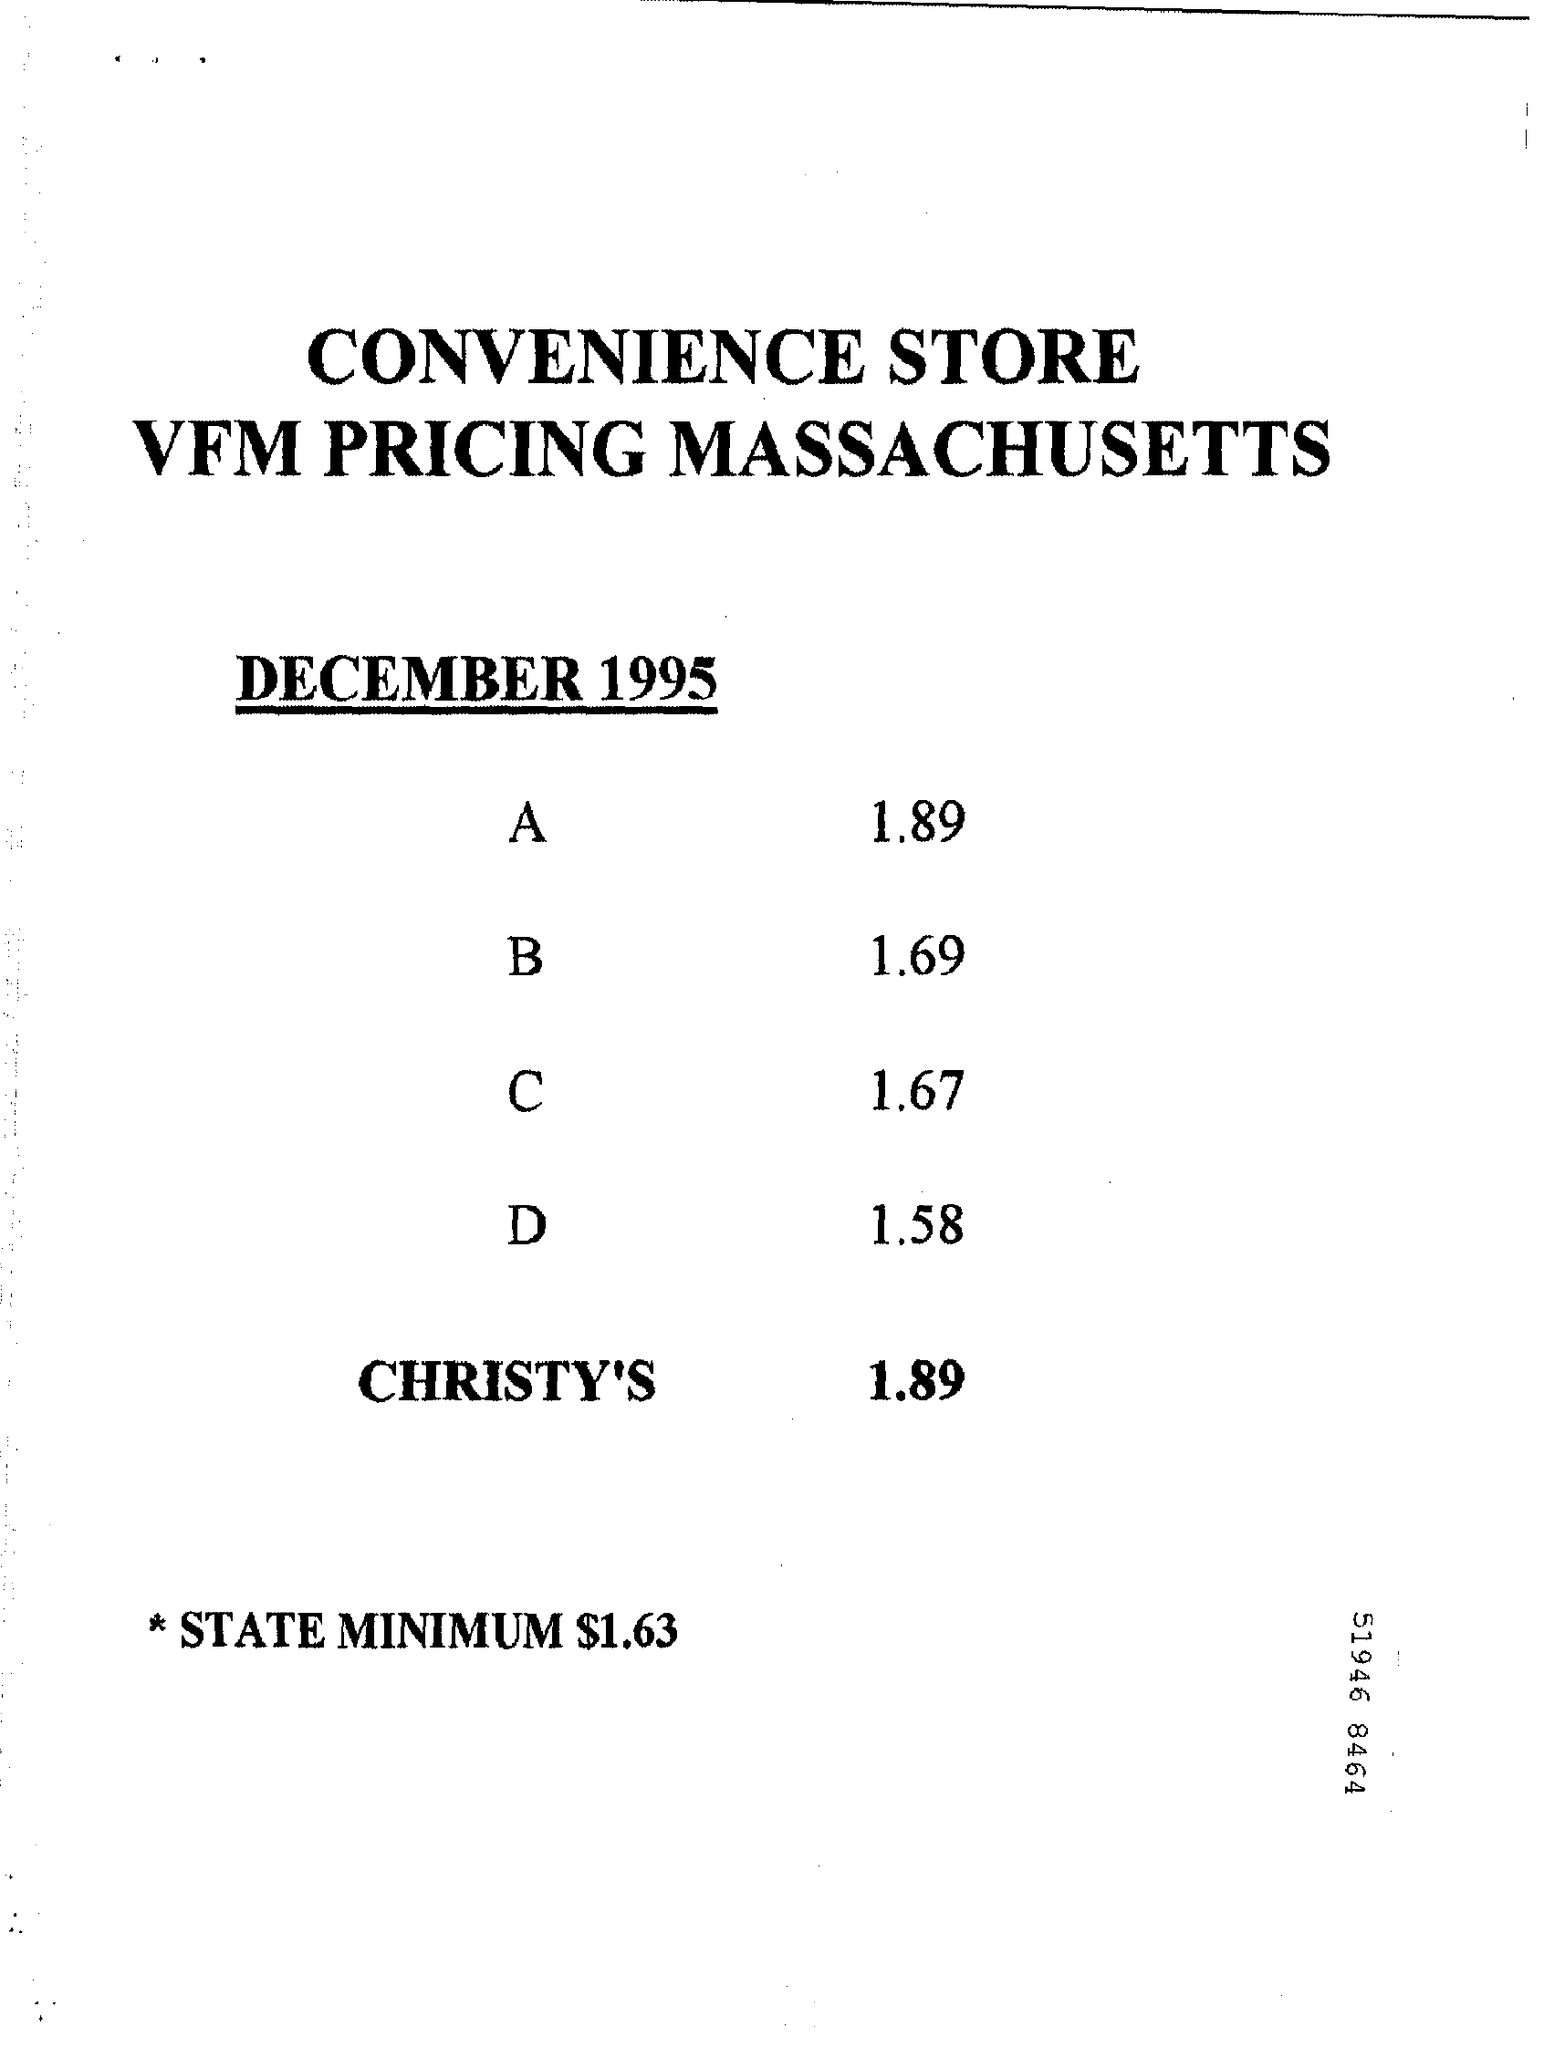What is the document title?
Provide a short and direct response. CONVENIENCE STORE VFM PRICING MASSACHUSETTS. When is the document dated?
Offer a very short reply. December 1995. What is the state minimum?
Provide a short and direct response. $1.63. 